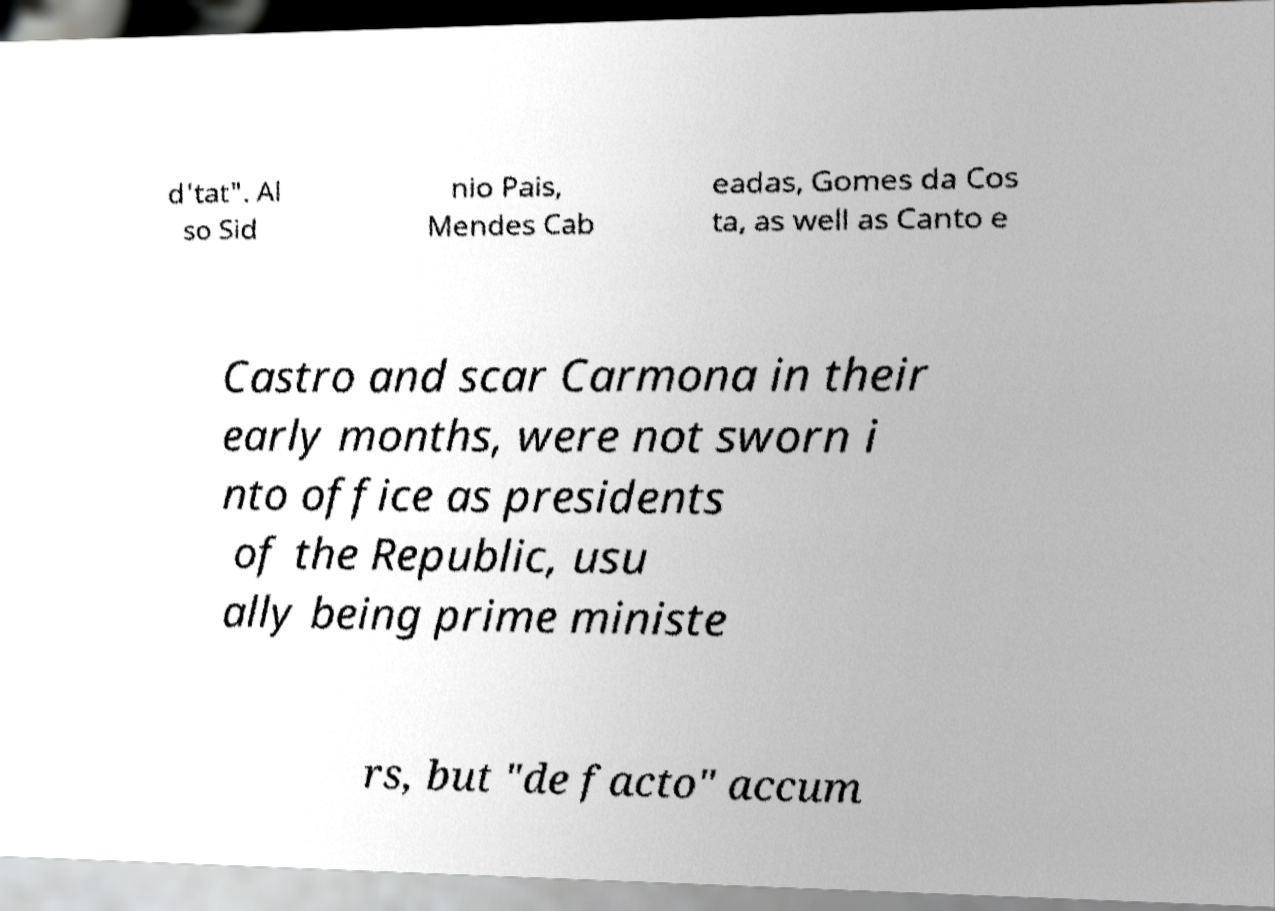Please read and relay the text visible in this image. What does it say? d'tat". Al so Sid nio Pais, Mendes Cab eadas, Gomes da Cos ta, as well as Canto e Castro and scar Carmona in their early months, were not sworn i nto office as presidents of the Republic, usu ally being prime ministe rs, but "de facto" accum 